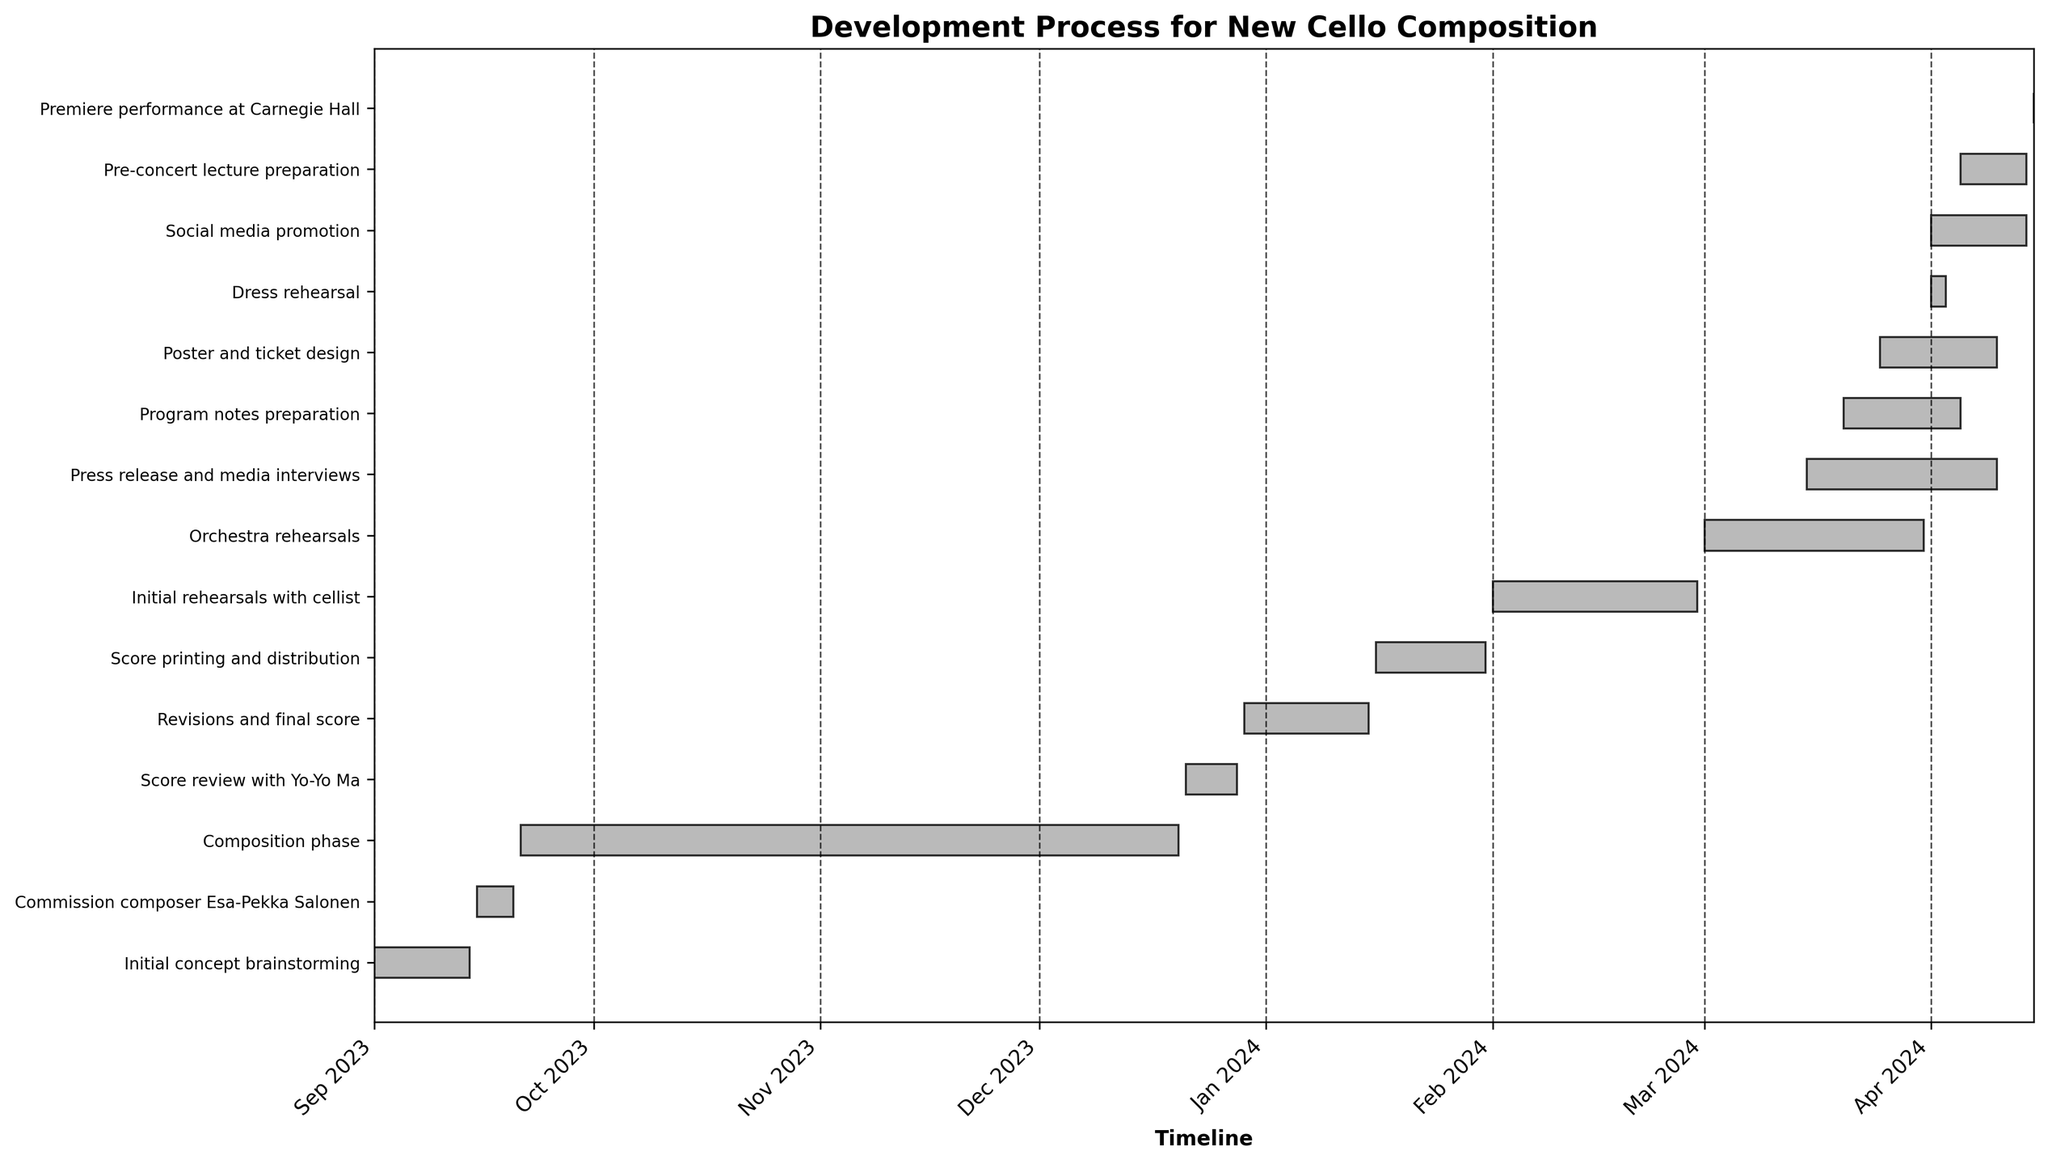What is the title of the chart? The title is displayed at the top of the plot. It summarizes the entire visual representation.
Answer: Development Process for New Cello Composition How many tasks are there in total? Each horizontal bar represents a task. Count the number of bars to determine the total number of tasks.
Answer: 16 When does the "Composition phase" start and end? Locate the "Composition phase" on the y-axis and refer to its corresponding start and end dates on the bar.
Answer: Starts on 2023-09-21 and ends on 2023-12-20 How long is the "Initial rehearsals with cellist"? Determine the duration by calculating the days between its start and end dates displayed on the bar.
Answer: 29 days Which task takes the longest time to complete? Compare the lengths of all the horizontal bars to identify the longest one.
Answer: Composition phase When does the "Score review with Yo-Yo Ma" occur? Locate this specific task on the y-axis and check its start and end dates.
Answer: 2023-12-21 to 2023-12-28 Which promotional activity starts the earliest? Examine the start dates of "Press release and media interviews," "Program notes preparation," "Poster and ticket design," "Social media promotion," and "Pre-concert lecture preparation" to find the earliest date.
Answer: Press release and media interviews How many days are allocated for "Score printing and distribution"? Calculate the difference between the start and end dates of "Score printing and distribution."
Answer: 16 days Does "Social media promotion" start before or after the "Dress rehearsal"? Compare the start dates of both tasks to check which one begins first.
Answer: After How many tasks take place simultaneously in March 2024? Identify tasks whose timelines overlap during March 2024 by checking their start and end dates.
Answer: 4 tasks 